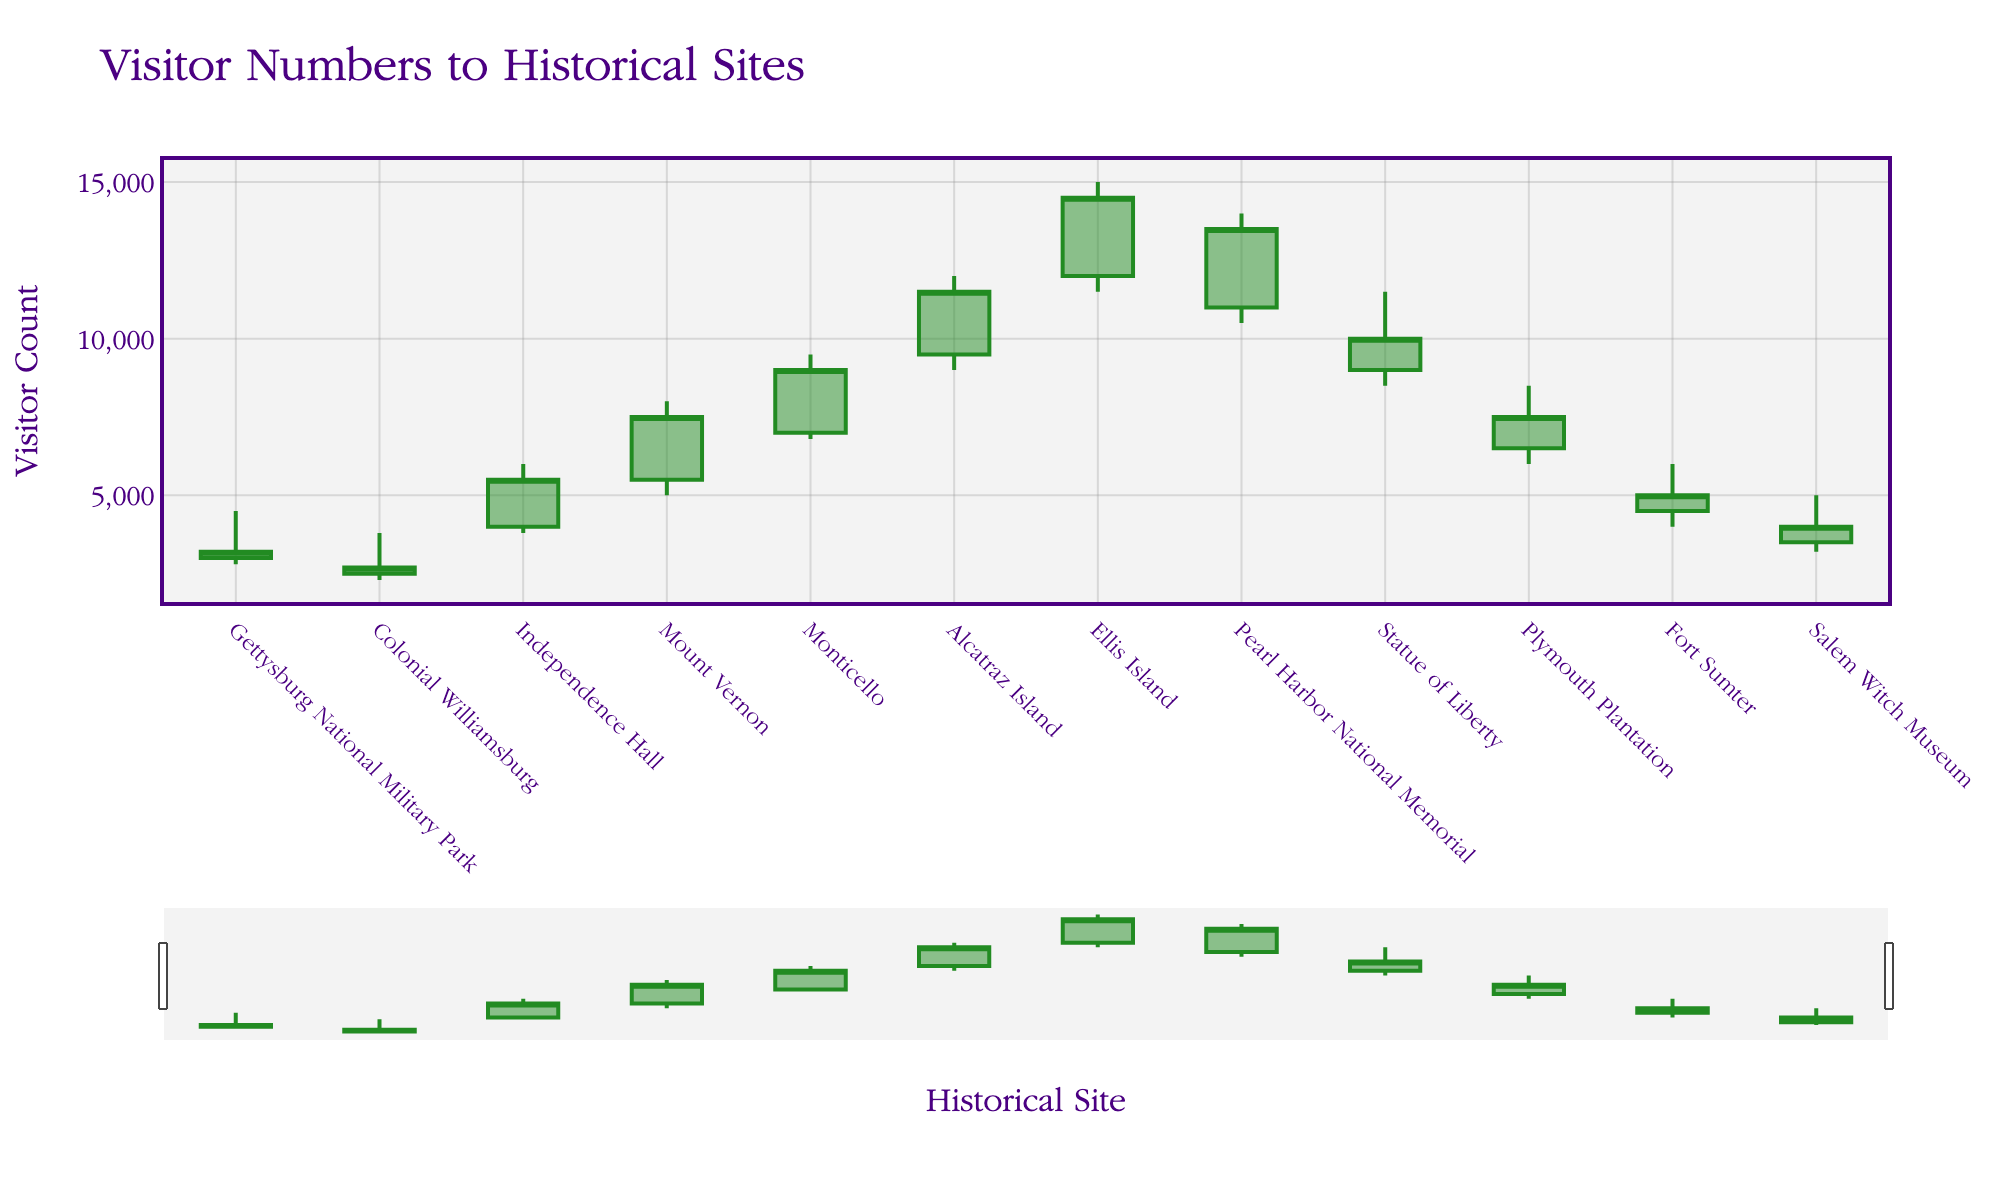What's the title of the figure? Look at the top of the figure where the title is displayed. It reads 'Visitor Numbers to Historical Sites'.
Answer: Visitor Numbers to Historical Sites What is the visitor count range for Alcatraz Island in June? Check the Open, High, Low, and Close values for Alcatraz Island in June. They range from 9000 to 12000.
Answer: 9000 to 12000 Which historical site had the highest visitor count in July? Look at the highest value (High) in July for all sites. Ellis Island has the highest value at 15000.
Answer: Ellis Island What is the visitor count difference between the highest and lowest points for Mount Vernon in April? Subtract the Low value from the High value for Mount Vernon in April. (8000 - 5000 = 3000)
Answer: 3000 During which month did Ellis Island experience its peak visitor count? Identify which month corresponds to Ellis Island and find the peak value, which is in July.
Answer: July Which site had a closing visitor count lower than its opening count for the month of October? Compare the Open and Close values for sites in October. Plymouth Plantation had a lower closing count (7500 < 6500).
Answer: Plymouth Plantation How many historical sites experienced an increasing trend in visitor numbers? Count the number of sites where the Close value is higher than the Open value. There are a total of 8 such sites.
Answer: 8 For Independence Hall in March, what is the average visitor count of the high and low values? Add the High and Low values and divide by 2. (6000 + 3800) / 2 = 4900
Answer: 4900 